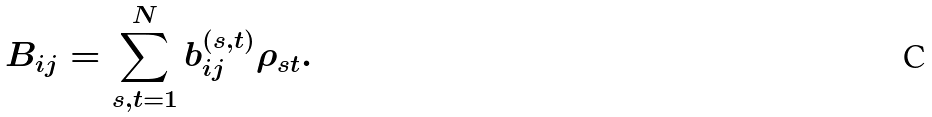<formula> <loc_0><loc_0><loc_500><loc_500>B _ { i j } = \sum _ { s , t = 1 } ^ { N } b _ { i j } ^ { ( s , t ) } \rho _ { s t } .</formula> 